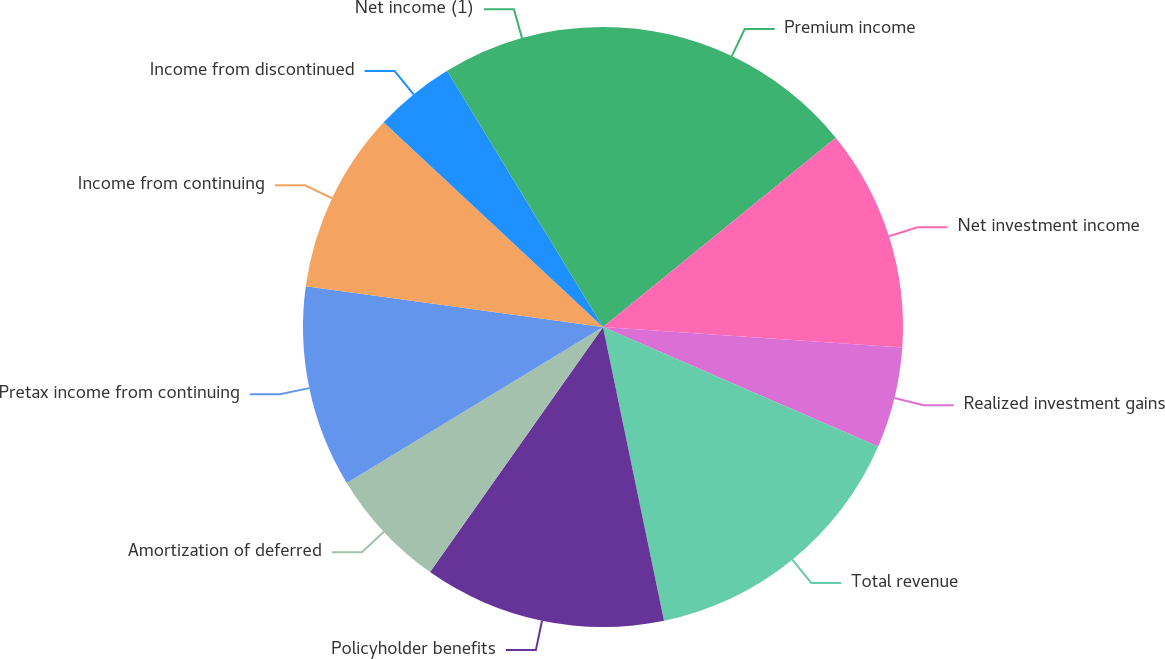<chart> <loc_0><loc_0><loc_500><loc_500><pie_chart><fcel>Premium income<fcel>Net investment income<fcel>Realized investment gains<fcel>Total revenue<fcel>Policyholder benefits<fcel>Amortization of deferred<fcel>Pretax income from continuing<fcel>Income from continuing<fcel>Income from discontinued<fcel>Net income (1)<nl><fcel>14.13%<fcel>11.96%<fcel>5.43%<fcel>15.22%<fcel>13.04%<fcel>6.52%<fcel>10.87%<fcel>9.78%<fcel>4.35%<fcel>8.7%<nl></chart> 